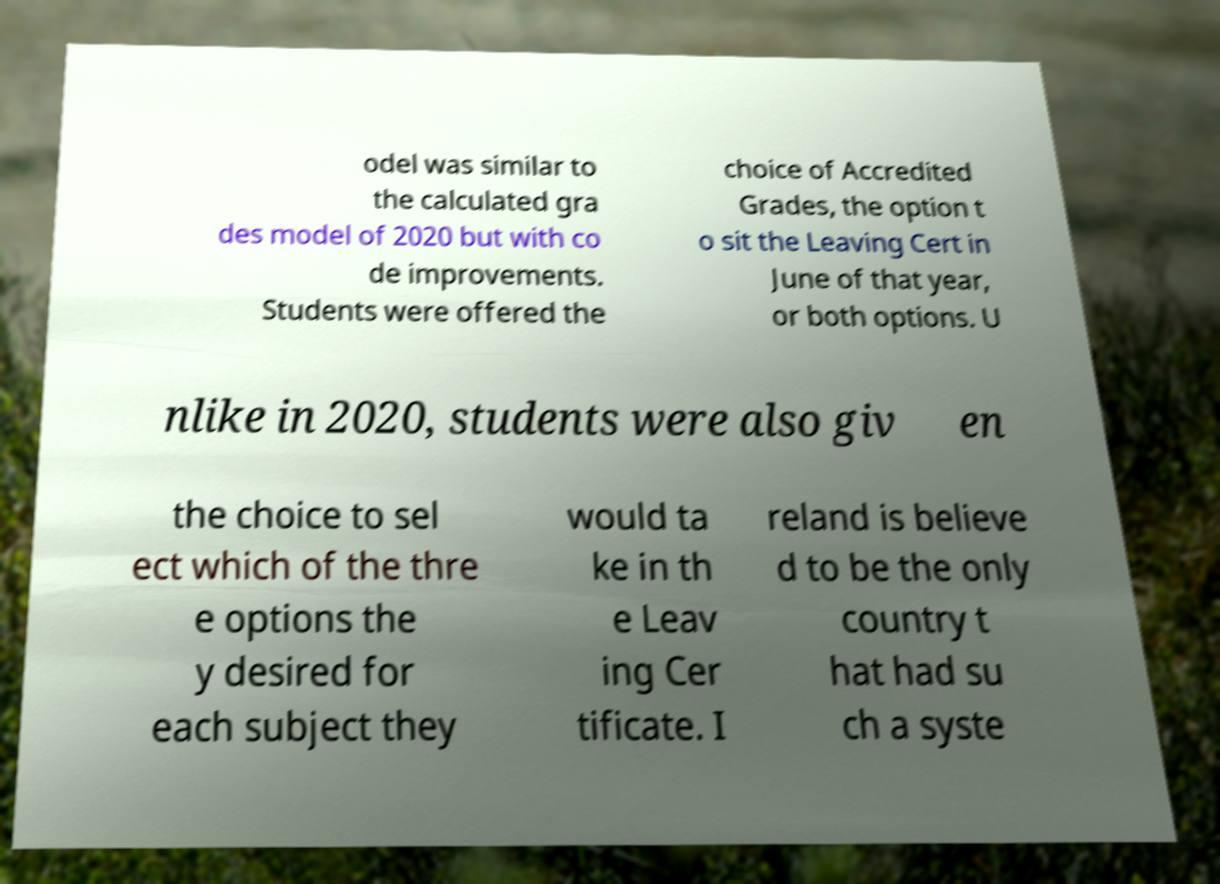There's text embedded in this image that I need extracted. Can you transcribe it verbatim? odel was similar to the calculated gra des model of 2020 but with co de improvements. Students were offered the choice of Accredited Grades, the option t o sit the Leaving Cert in June of that year, or both options. U nlike in 2020, students were also giv en the choice to sel ect which of the thre e options the y desired for each subject they would ta ke in th e Leav ing Cer tificate. I reland is believe d to be the only country t hat had su ch a syste 